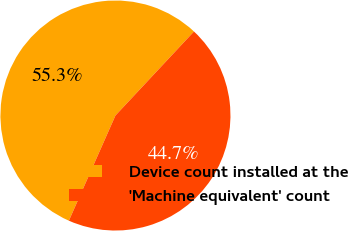Convert chart. <chart><loc_0><loc_0><loc_500><loc_500><pie_chart><fcel>Device count installed at the<fcel>'Machine equivalent' count<nl><fcel>55.33%<fcel>44.67%<nl></chart> 